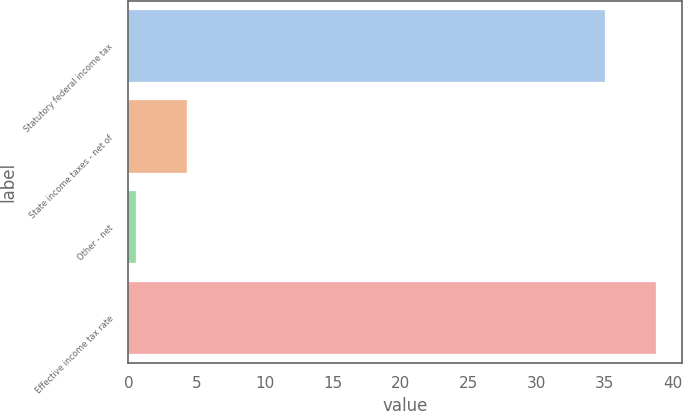<chart> <loc_0><loc_0><loc_500><loc_500><bar_chart><fcel>Statutory federal income tax<fcel>State income taxes - net of<fcel>Other - net<fcel>Effective income tax rate<nl><fcel>35<fcel>4.34<fcel>0.6<fcel>38.74<nl></chart> 